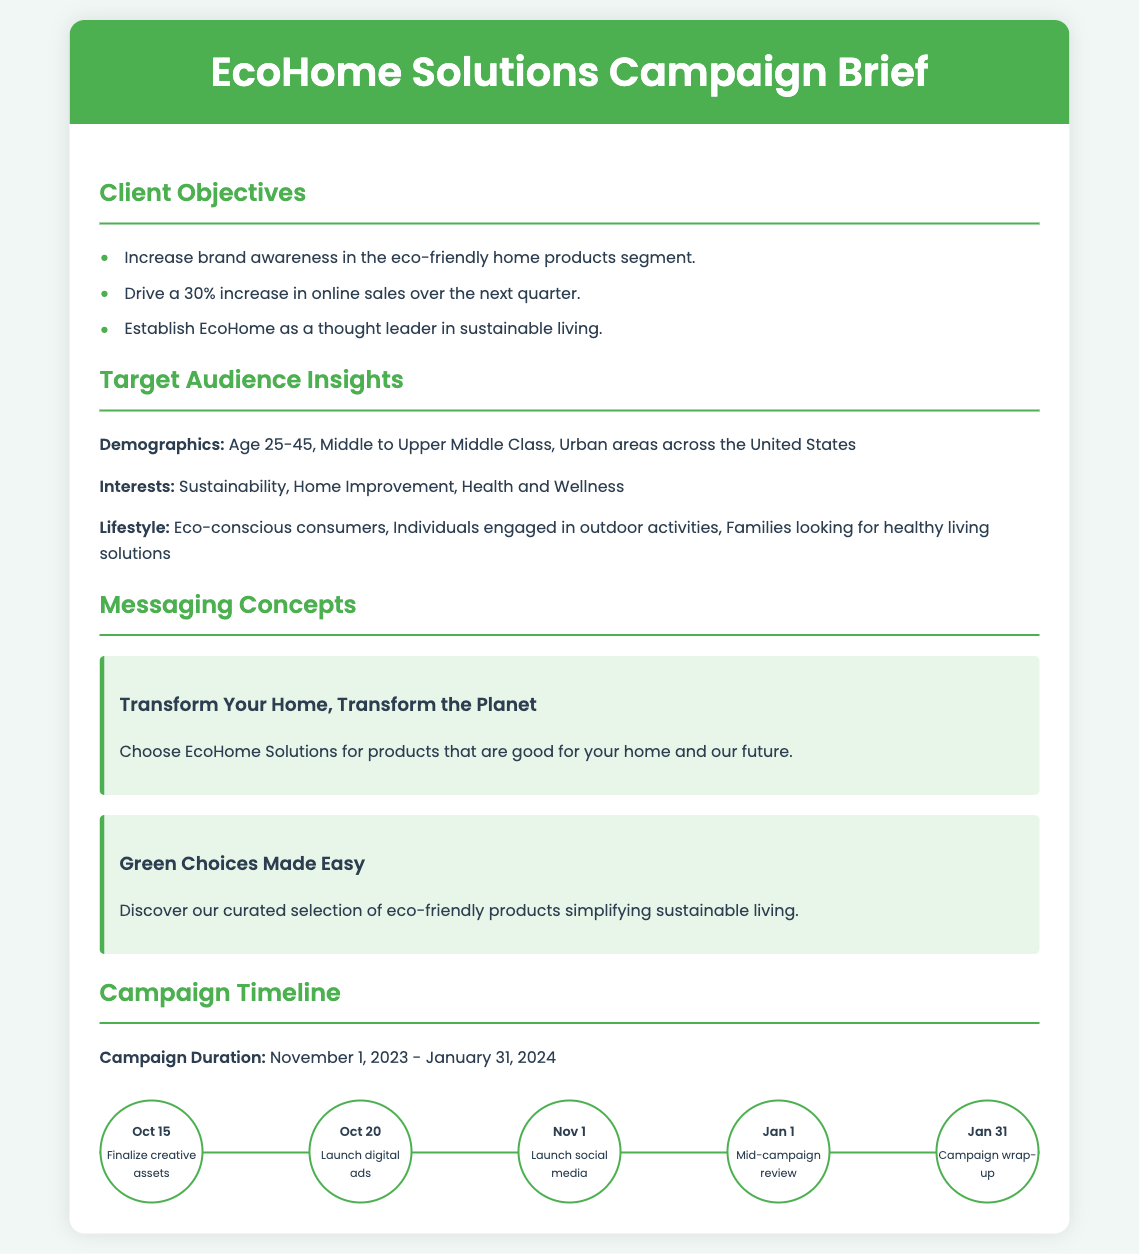What are the client objectives? The document lists three specific client objectives regarding brand awareness and sales.
Answer: Increase brand awareness in the eco-friendly home products segment, drive a 30% increase in online sales over the next quarter, establish EcoHome as a thought leader in sustainable living What is the target demographic age range? The target audience demographics specify the age group targeted for the campaign.
Answer: Age 25-45 What is the campaign duration? The timeline section outlines the duration of the campaign and the start and end dates.
Answer: November 1, 2023 - January 31, 2024 What is one messaging concept presented in the brief? The messaging concepts section contains two key messages promoting EcoHome Solutions.
Answer: Transform Your Home, Transform the Planet On what date are digital ads scheduled to launch? The timeline provides specific milestone dates for various campaign activities.
Answer: October 20 What is the main interest of the target audience? The document outlines the interests of the target audience as part of the insights.
Answer: Sustainability What is the purpose of the campaign's mid-review? The timeline includes a mid-campaign review that aims to assess progress.
Answer: Mid-campaign review What type of consumer activity is targeted in the lifestyle description? The lifestyle section provides insight into the activities of the target audience.
Answer: Outdoor activities 